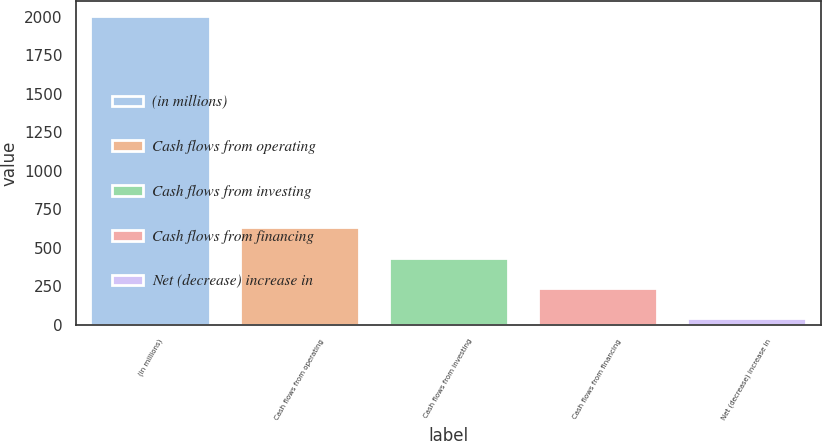Convert chart to OTSL. <chart><loc_0><loc_0><loc_500><loc_500><bar_chart><fcel>(in millions)<fcel>Cash flows from operating<fcel>Cash flows from investing<fcel>Cash flows from financing<fcel>Net (decrease) increase in<nl><fcel>2004<fcel>632.56<fcel>436.64<fcel>240.72<fcel>44.8<nl></chart> 